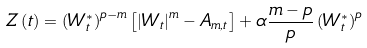Convert formula to latex. <formula><loc_0><loc_0><loc_500><loc_500>Z \left ( t \right ) = \left ( W _ { t } ^ { \ast } \right ) ^ { p - m } \left [ \left | W _ { t } \right | ^ { m } - A _ { m , t } \right ] + \alpha \frac { m - p } { p } \left ( W _ { t } ^ { \ast } \right ) ^ { p }</formula> 